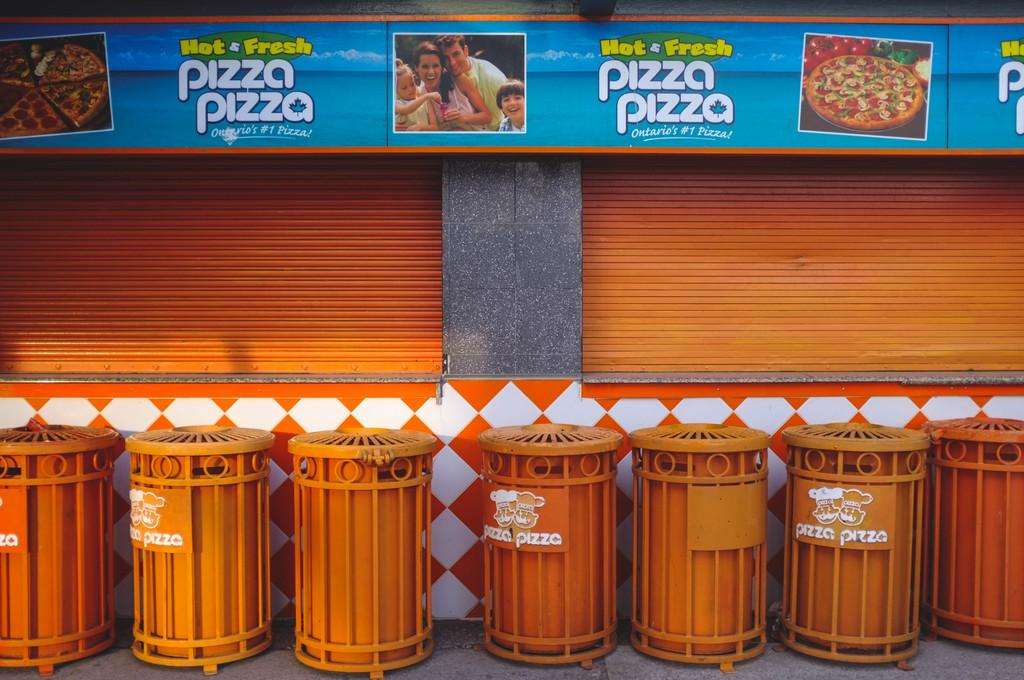<image>
Share a concise interpretation of the image provided. Hot and Fresh Pizza Pizza that says Ontatio's #1 Pizza. 